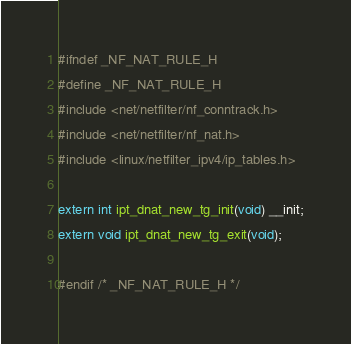<code> <loc_0><loc_0><loc_500><loc_500><_C_>#ifndef _NF_NAT_RULE_H
#define _NF_NAT_RULE_H
#include <net/netfilter/nf_conntrack.h>
#include <net/netfilter/nf_nat.h>
#include <linux/netfilter_ipv4/ip_tables.h>

extern int ipt_dnat_new_tg_init(void) __init;
extern void ipt_dnat_new_tg_exit(void);

#endif /* _NF_NAT_RULE_H */

</code> 